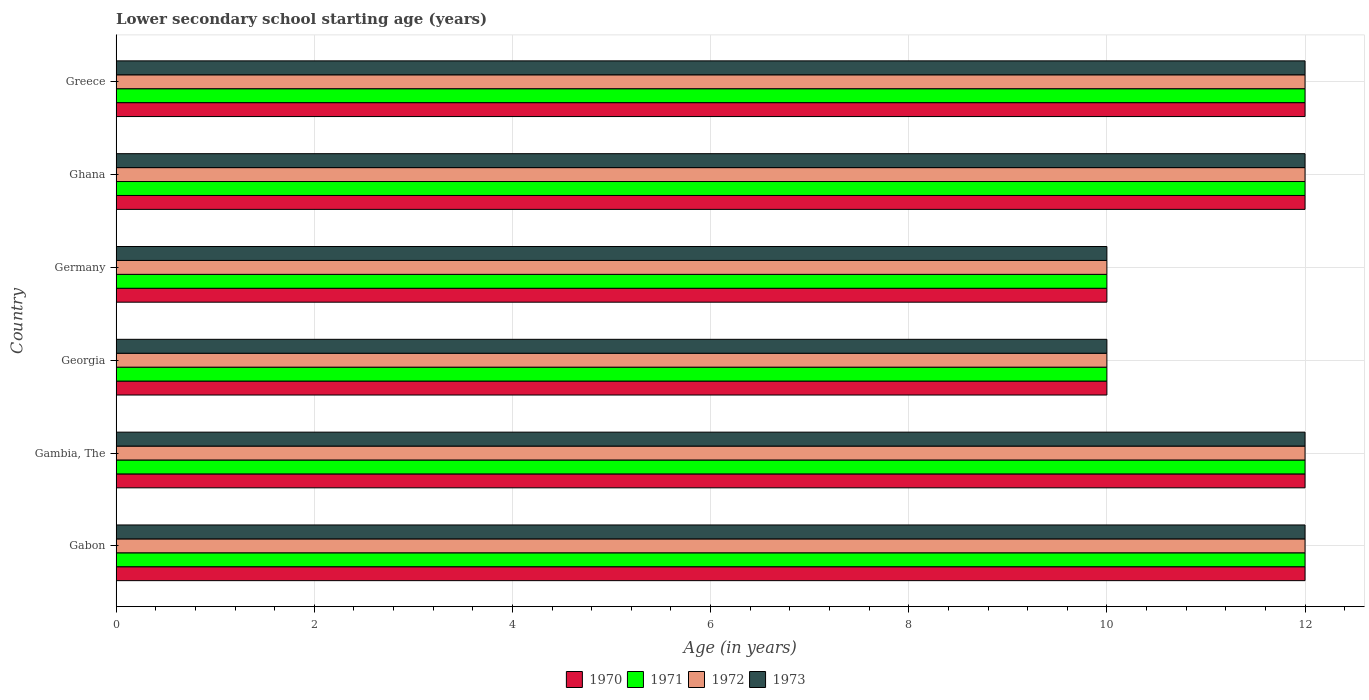How many different coloured bars are there?
Provide a succinct answer. 4. Are the number of bars per tick equal to the number of legend labels?
Make the answer very short. Yes. How many bars are there on the 5th tick from the top?
Offer a very short reply. 4. What is the label of the 2nd group of bars from the top?
Your response must be concise. Ghana. In how many cases, is the number of bars for a given country not equal to the number of legend labels?
Offer a terse response. 0. Across all countries, what is the maximum lower secondary school starting age of children in 1970?
Give a very brief answer. 12. Across all countries, what is the minimum lower secondary school starting age of children in 1971?
Your answer should be compact. 10. In which country was the lower secondary school starting age of children in 1972 maximum?
Provide a succinct answer. Gabon. In which country was the lower secondary school starting age of children in 1971 minimum?
Provide a short and direct response. Georgia. What is the total lower secondary school starting age of children in 1972 in the graph?
Ensure brevity in your answer.  68. What is the average lower secondary school starting age of children in 1971 per country?
Make the answer very short. 11.33. What is the difference between the lower secondary school starting age of children in 1970 and lower secondary school starting age of children in 1971 in Gabon?
Provide a succinct answer. 0. In how many countries, is the lower secondary school starting age of children in 1970 greater than 7.6 years?
Keep it short and to the point. 6. What is the ratio of the lower secondary school starting age of children in 1971 in Gabon to that in Greece?
Give a very brief answer. 1. Is the lower secondary school starting age of children in 1970 in Ghana less than that in Greece?
Provide a succinct answer. No. Is the difference between the lower secondary school starting age of children in 1970 in Gabon and Georgia greater than the difference between the lower secondary school starting age of children in 1971 in Gabon and Georgia?
Give a very brief answer. No. Is it the case that in every country, the sum of the lower secondary school starting age of children in 1971 and lower secondary school starting age of children in 1973 is greater than the sum of lower secondary school starting age of children in 1970 and lower secondary school starting age of children in 1972?
Give a very brief answer. No. What does the 2nd bar from the bottom in Greece represents?
Your answer should be compact. 1971. Is it the case that in every country, the sum of the lower secondary school starting age of children in 1973 and lower secondary school starting age of children in 1970 is greater than the lower secondary school starting age of children in 1971?
Make the answer very short. Yes. Are all the bars in the graph horizontal?
Your answer should be very brief. Yes. How many countries are there in the graph?
Ensure brevity in your answer.  6. Are the values on the major ticks of X-axis written in scientific E-notation?
Keep it short and to the point. No. Does the graph contain grids?
Your response must be concise. Yes. What is the title of the graph?
Your answer should be very brief. Lower secondary school starting age (years). Does "1998" appear as one of the legend labels in the graph?
Ensure brevity in your answer.  No. What is the label or title of the X-axis?
Ensure brevity in your answer.  Age (in years). What is the Age (in years) of 1970 in Gabon?
Ensure brevity in your answer.  12. What is the Age (in years) of 1971 in Gabon?
Ensure brevity in your answer.  12. What is the Age (in years) of 1973 in Gabon?
Offer a terse response. 12. What is the Age (in years) of 1970 in Gambia, The?
Your response must be concise. 12. What is the Age (in years) in 1973 in Gambia, The?
Give a very brief answer. 12. What is the Age (in years) in 1970 in Georgia?
Provide a succinct answer. 10. What is the Age (in years) in 1971 in Georgia?
Provide a short and direct response. 10. What is the Age (in years) in 1970 in Germany?
Provide a short and direct response. 10. What is the Age (in years) of 1972 in Ghana?
Your answer should be very brief. 12. What is the Age (in years) in 1973 in Ghana?
Ensure brevity in your answer.  12. What is the Age (in years) of 1970 in Greece?
Give a very brief answer. 12. What is the Age (in years) in 1971 in Greece?
Your response must be concise. 12. What is the Age (in years) in 1972 in Greece?
Make the answer very short. 12. Across all countries, what is the maximum Age (in years) of 1970?
Ensure brevity in your answer.  12. Across all countries, what is the maximum Age (in years) of 1971?
Ensure brevity in your answer.  12. Across all countries, what is the maximum Age (in years) in 1973?
Ensure brevity in your answer.  12. Across all countries, what is the minimum Age (in years) of 1971?
Give a very brief answer. 10. Across all countries, what is the minimum Age (in years) of 1972?
Give a very brief answer. 10. What is the total Age (in years) in 1970 in the graph?
Keep it short and to the point. 68. What is the total Age (in years) of 1971 in the graph?
Your answer should be compact. 68. What is the total Age (in years) of 1972 in the graph?
Provide a short and direct response. 68. What is the total Age (in years) of 1973 in the graph?
Your response must be concise. 68. What is the difference between the Age (in years) of 1972 in Gabon and that in Gambia, The?
Your answer should be very brief. 0. What is the difference between the Age (in years) of 1970 in Gabon and that in Georgia?
Provide a succinct answer. 2. What is the difference between the Age (in years) of 1973 in Gabon and that in Georgia?
Keep it short and to the point. 2. What is the difference between the Age (in years) in 1970 in Gabon and that in Germany?
Provide a short and direct response. 2. What is the difference between the Age (in years) of 1972 in Gabon and that in Germany?
Offer a very short reply. 2. What is the difference between the Age (in years) in 1973 in Gabon and that in Germany?
Your answer should be compact. 2. What is the difference between the Age (in years) of 1971 in Gabon and that in Ghana?
Ensure brevity in your answer.  0. What is the difference between the Age (in years) of 1972 in Gabon and that in Ghana?
Offer a very short reply. 0. What is the difference between the Age (in years) in 1973 in Gabon and that in Ghana?
Offer a terse response. 0. What is the difference between the Age (in years) of 1970 in Gabon and that in Greece?
Your answer should be compact. 0. What is the difference between the Age (in years) of 1971 in Gambia, The and that in Georgia?
Offer a terse response. 2. What is the difference between the Age (in years) in 1972 in Gambia, The and that in Georgia?
Keep it short and to the point. 2. What is the difference between the Age (in years) in 1973 in Gambia, The and that in Georgia?
Keep it short and to the point. 2. What is the difference between the Age (in years) in 1972 in Gambia, The and that in Germany?
Provide a succinct answer. 2. What is the difference between the Age (in years) of 1970 in Gambia, The and that in Ghana?
Offer a terse response. 0. What is the difference between the Age (in years) in 1972 in Gambia, The and that in Greece?
Offer a terse response. 0. What is the difference between the Age (in years) in 1971 in Georgia and that in Germany?
Ensure brevity in your answer.  0. What is the difference between the Age (in years) of 1972 in Georgia and that in Germany?
Provide a short and direct response. 0. What is the difference between the Age (in years) in 1970 in Georgia and that in Ghana?
Offer a very short reply. -2. What is the difference between the Age (in years) of 1971 in Georgia and that in Ghana?
Provide a short and direct response. -2. What is the difference between the Age (in years) in 1972 in Georgia and that in Ghana?
Give a very brief answer. -2. What is the difference between the Age (in years) in 1971 in Georgia and that in Greece?
Provide a succinct answer. -2. What is the difference between the Age (in years) of 1972 in Georgia and that in Greece?
Keep it short and to the point. -2. What is the difference between the Age (in years) in 1970 in Germany and that in Ghana?
Your answer should be very brief. -2. What is the difference between the Age (in years) of 1972 in Germany and that in Ghana?
Keep it short and to the point. -2. What is the difference between the Age (in years) in 1970 in Germany and that in Greece?
Your answer should be compact. -2. What is the difference between the Age (in years) of 1971 in Germany and that in Greece?
Ensure brevity in your answer.  -2. What is the difference between the Age (in years) in 1972 in Germany and that in Greece?
Offer a very short reply. -2. What is the difference between the Age (in years) of 1970 in Ghana and that in Greece?
Give a very brief answer. 0. What is the difference between the Age (in years) in 1971 in Ghana and that in Greece?
Your answer should be very brief. 0. What is the difference between the Age (in years) in 1972 in Ghana and that in Greece?
Give a very brief answer. 0. What is the difference between the Age (in years) of 1970 in Gabon and the Age (in years) of 1971 in Gambia, The?
Keep it short and to the point. 0. What is the difference between the Age (in years) of 1971 in Gabon and the Age (in years) of 1972 in Gambia, The?
Your response must be concise. 0. What is the difference between the Age (in years) in 1970 in Gabon and the Age (in years) in 1972 in Georgia?
Offer a terse response. 2. What is the difference between the Age (in years) of 1971 in Gabon and the Age (in years) of 1973 in Georgia?
Your answer should be very brief. 2. What is the difference between the Age (in years) of 1970 in Gabon and the Age (in years) of 1972 in Germany?
Make the answer very short. 2. What is the difference between the Age (in years) in 1972 in Gabon and the Age (in years) in 1973 in Germany?
Make the answer very short. 2. What is the difference between the Age (in years) of 1970 in Gabon and the Age (in years) of 1972 in Ghana?
Offer a terse response. 0. What is the difference between the Age (in years) of 1970 in Gabon and the Age (in years) of 1973 in Ghana?
Your answer should be very brief. 0. What is the difference between the Age (in years) of 1971 in Gabon and the Age (in years) of 1973 in Ghana?
Make the answer very short. 0. What is the difference between the Age (in years) of 1970 in Gabon and the Age (in years) of 1972 in Greece?
Provide a succinct answer. 0. What is the difference between the Age (in years) in 1970 in Gambia, The and the Age (in years) in 1973 in Georgia?
Give a very brief answer. 2. What is the difference between the Age (in years) in 1970 in Gambia, The and the Age (in years) in 1971 in Germany?
Make the answer very short. 2. What is the difference between the Age (in years) in 1970 in Gambia, The and the Age (in years) in 1972 in Germany?
Offer a very short reply. 2. What is the difference between the Age (in years) of 1970 in Gambia, The and the Age (in years) of 1973 in Germany?
Ensure brevity in your answer.  2. What is the difference between the Age (in years) of 1971 in Gambia, The and the Age (in years) of 1973 in Germany?
Ensure brevity in your answer.  2. What is the difference between the Age (in years) in 1972 in Gambia, The and the Age (in years) in 1973 in Germany?
Keep it short and to the point. 2. What is the difference between the Age (in years) in 1970 in Gambia, The and the Age (in years) in 1971 in Ghana?
Provide a succinct answer. 0. What is the difference between the Age (in years) of 1971 in Gambia, The and the Age (in years) of 1973 in Ghana?
Provide a short and direct response. 0. What is the difference between the Age (in years) in 1972 in Gambia, The and the Age (in years) in 1973 in Ghana?
Your response must be concise. 0. What is the difference between the Age (in years) in 1970 in Gambia, The and the Age (in years) in 1972 in Greece?
Ensure brevity in your answer.  0. What is the difference between the Age (in years) of 1971 in Gambia, The and the Age (in years) of 1973 in Greece?
Give a very brief answer. 0. What is the difference between the Age (in years) in 1972 in Gambia, The and the Age (in years) in 1973 in Greece?
Offer a terse response. 0. What is the difference between the Age (in years) of 1971 in Georgia and the Age (in years) of 1972 in Germany?
Your response must be concise. 0. What is the difference between the Age (in years) in 1972 in Georgia and the Age (in years) in 1973 in Germany?
Give a very brief answer. 0. What is the difference between the Age (in years) of 1970 in Georgia and the Age (in years) of 1971 in Ghana?
Make the answer very short. -2. What is the difference between the Age (in years) in 1970 in Georgia and the Age (in years) in 1972 in Ghana?
Provide a short and direct response. -2. What is the difference between the Age (in years) of 1972 in Georgia and the Age (in years) of 1973 in Ghana?
Ensure brevity in your answer.  -2. What is the difference between the Age (in years) of 1970 in Georgia and the Age (in years) of 1973 in Greece?
Your answer should be compact. -2. What is the difference between the Age (in years) in 1971 in Georgia and the Age (in years) in 1972 in Greece?
Your answer should be very brief. -2. What is the difference between the Age (in years) in 1972 in Georgia and the Age (in years) in 1973 in Greece?
Make the answer very short. -2. What is the difference between the Age (in years) in 1970 in Germany and the Age (in years) in 1971 in Ghana?
Offer a terse response. -2. What is the difference between the Age (in years) of 1970 in Germany and the Age (in years) of 1972 in Ghana?
Your answer should be very brief. -2. What is the difference between the Age (in years) of 1970 in Germany and the Age (in years) of 1973 in Ghana?
Offer a very short reply. -2. What is the difference between the Age (in years) of 1971 in Germany and the Age (in years) of 1972 in Ghana?
Provide a short and direct response. -2. What is the difference between the Age (in years) in 1971 in Germany and the Age (in years) in 1973 in Ghana?
Offer a terse response. -2. What is the difference between the Age (in years) in 1972 in Germany and the Age (in years) in 1973 in Ghana?
Offer a very short reply. -2. What is the difference between the Age (in years) in 1970 in Germany and the Age (in years) in 1971 in Greece?
Your answer should be compact. -2. What is the difference between the Age (in years) in 1971 in Germany and the Age (in years) in 1972 in Greece?
Your response must be concise. -2. What is the difference between the Age (in years) of 1972 in Germany and the Age (in years) of 1973 in Greece?
Provide a short and direct response. -2. What is the difference between the Age (in years) in 1970 in Ghana and the Age (in years) in 1971 in Greece?
Provide a succinct answer. 0. What is the difference between the Age (in years) of 1970 in Ghana and the Age (in years) of 1972 in Greece?
Your answer should be compact. 0. What is the difference between the Age (in years) in 1971 in Ghana and the Age (in years) in 1972 in Greece?
Provide a short and direct response. 0. What is the difference between the Age (in years) in 1971 in Ghana and the Age (in years) in 1973 in Greece?
Make the answer very short. 0. What is the average Age (in years) of 1970 per country?
Make the answer very short. 11.33. What is the average Age (in years) of 1971 per country?
Keep it short and to the point. 11.33. What is the average Age (in years) of 1972 per country?
Provide a short and direct response. 11.33. What is the average Age (in years) in 1973 per country?
Ensure brevity in your answer.  11.33. What is the difference between the Age (in years) in 1970 and Age (in years) in 1971 in Gabon?
Make the answer very short. 0. What is the difference between the Age (in years) in 1971 and Age (in years) in 1972 in Gabon?
Your answer should be compact. 0. What is the difference between the Age (in years) in 1970 and Age (in years) in 1971 in Gambia, The?
Make the answer very short. 0. What is the difference between the Age (in years) of 1970 and Age (in years) of 1973 in Gambia, The?
Offer a terse response. 0. What is the difference between the Age (in years) of 1971 and Age (in years) of 1972 in Gambia, The?
Keep it short and to the point. 0. What is the difference between the Age (in years) in 1970 and Age (in years) in 1972 in Georgia?
Your response must be concise. 0. What is the difference between the Age (in years) in 1971 and Age (in years) in 1973 in Georgia?
Offer a terse response. 0. What is the difference between the Age (in years) in 1970 and Age (in years) in 1972 in Germany?
Offer a very short reply. 0. What is the difference between the Age (in years) in 1971 and Age (in years) in 1972 in Germany?
Offer a very short reply. 0. What is the difference between the Age (in years) in 1970 and Age (in years) in 1972 in Ghana?
Your response must be concise. 0. What is the difference between the Age (in years) in 1972 and Age (in years) in 1973 in Ghana?
Your response must be concise. 0. What is the difference between the Age (in years) of 1970 and Age (in years) of 1971 in Greece?
Your answer should be very brief. 0. What is the difference between the Age (in years) in 1970 and Age (in years) in 1973 in Greece?
Your answer should be compact. 0. What is the difference between the Age (in years) of 1971 and Age (in years) of 1972 in Greece?
Your answer should be compact. 0. What is the ratio of the Age (in years) in 1970 in Gabon to that in Gambia, The?
Ensure brevity in your answer.  1. What is the ratio of the Age (in years) of 1971 in Gabon to that in Gambia, The?
Offer a terse response. 1. What is the ratio of the Age (in years) in 1971 in Gabon to that in Georgia?
Ensure brevity in your answer.  1.2. What is the ratio of the Age (in years) of 1970 in Gabon to that in Germany?
Make the answer very short. 1.2. What is the ratio of the Age (in years) of 1972 in Gabon to that in Germany?
Ensure brevity in your answer.  1.2. What is the ratio of the Age (in years) of 1973 in Gabon to that in Germany?
Make the answer very short. 1.2. What is the ratio of the Age (in years) in 1970 in Gabon to that in Ghana?
Provide a short and direct response. 1. What is the ratio of the Age (in years) in 1972 in Gabon to that in Ghana?
Offer a very short reply. 1. What is the ratio of the Age (in years) of 1971 in Gabon to that in Greece?
Your response must be concise. 1. What is the ratio of the Age (in years) of 1970 in Gambia, The to that in Georgia?
Give a very brief answer. 1.2. What is the ratio of the Age (in years) of 1971 in Gambia, The to that in Georgia?
Make the answer very short. 1.2. What is the ratio of the Age (in years) in 1972 in Gambia, The to that in Georgia?
Your answer should be very brief. 1.2. What is the ratio of the Age (in years) in 1971 in Gambia, The to that in Germany?
Provide a succinct answer. 1.2. What is the ratio of the Age (in years) in 1973 in Gambia, The to that in Germany?
Offer a very short reply. 1.2. What is the ratio of the Age (in years) in 1970 in Gambia, The to that in Ghana?
Provide a succinct answer. 1. What is the ratio of the Age (in years) of 1971 in Gambia, The to that in Ghana?
Give a very brief answer. 1. What is the ratio of the Age (in years) in 1972 in Gambia, The to that in Ghana?
Offer a very short reply. 1. What is the ratio of the Age (in years) in 1970 in Gambia, The to that in Greece?
Your answer should be very brief. 1. What is the ratio of the Age (in years) of 1971 in Gambia, The to that in Greece?
Keep it short and to the point. 1. What is the ratio of the Age (in years) in 1973 in Gambia, The to that in Greece?
Offer a very short reply. 1. What is the ratio of the Age (in years) of 1971 in Georgia to that in Germany?
Keep it short and to the point. 1. What is the ratio of the Age (in years) of 1970 in Georgia to that in Ghana?
Ensure brevity in your answer.  0.83. What is the ratio of the Age (in years) of 1973 in Georgia to that in Greece?
Provide a succinct answer. 0.83. What is the ratio of the Age (in years) in 1970 in Germany to that in Ghana?
Your response must be concise. 0.83. What is the ratio of the Age (in years) of 1971 in Germany to that in Ghana?
Ensure brevity in your answer.  0.83. What is the ratio of the Age (in years) of 1972 in Germany to that in Ghana?
Your response must be concise. 0.83. What is the ratio of the Age (in years) in 1970 in Germany to that in Greece?
Keep it short and to the point. 0.83. What is the ratio of the Age (in years) in 1972 in Germany to that in Greece?
Ensure brevity in your answer.  0.83. What is the ratio of the Age (in years) of 1970 in Ghana to that in Greece?
Keep it short and to the point. 1. What is the ratio of the Age (in years) in 1972 in Ghana to that in Greece?
Provide a short and direct response. 1. What is the ratio of the Age (in years) of 1973 in Ghana to that in Greece?
Your response must be concise. 1. What is the difference between the highest and the second highest Age (in years) of 1970?
Give a very brief answer. 0. What is the difference between the highest and the second highest Age (in years) of 1971?
Ensure brevity in your answer.  0. What is the difference between the highest and the second highest Age (in years) of 1973?
Ensure brevity in your answer.  0. What is the difference between the highest and the lowest Age (in years) of 1972?
Offer a terse response. 2. What is the difference between the highest and the lowest Age (in years) of 1973?
Your answer should be compact. 2. 